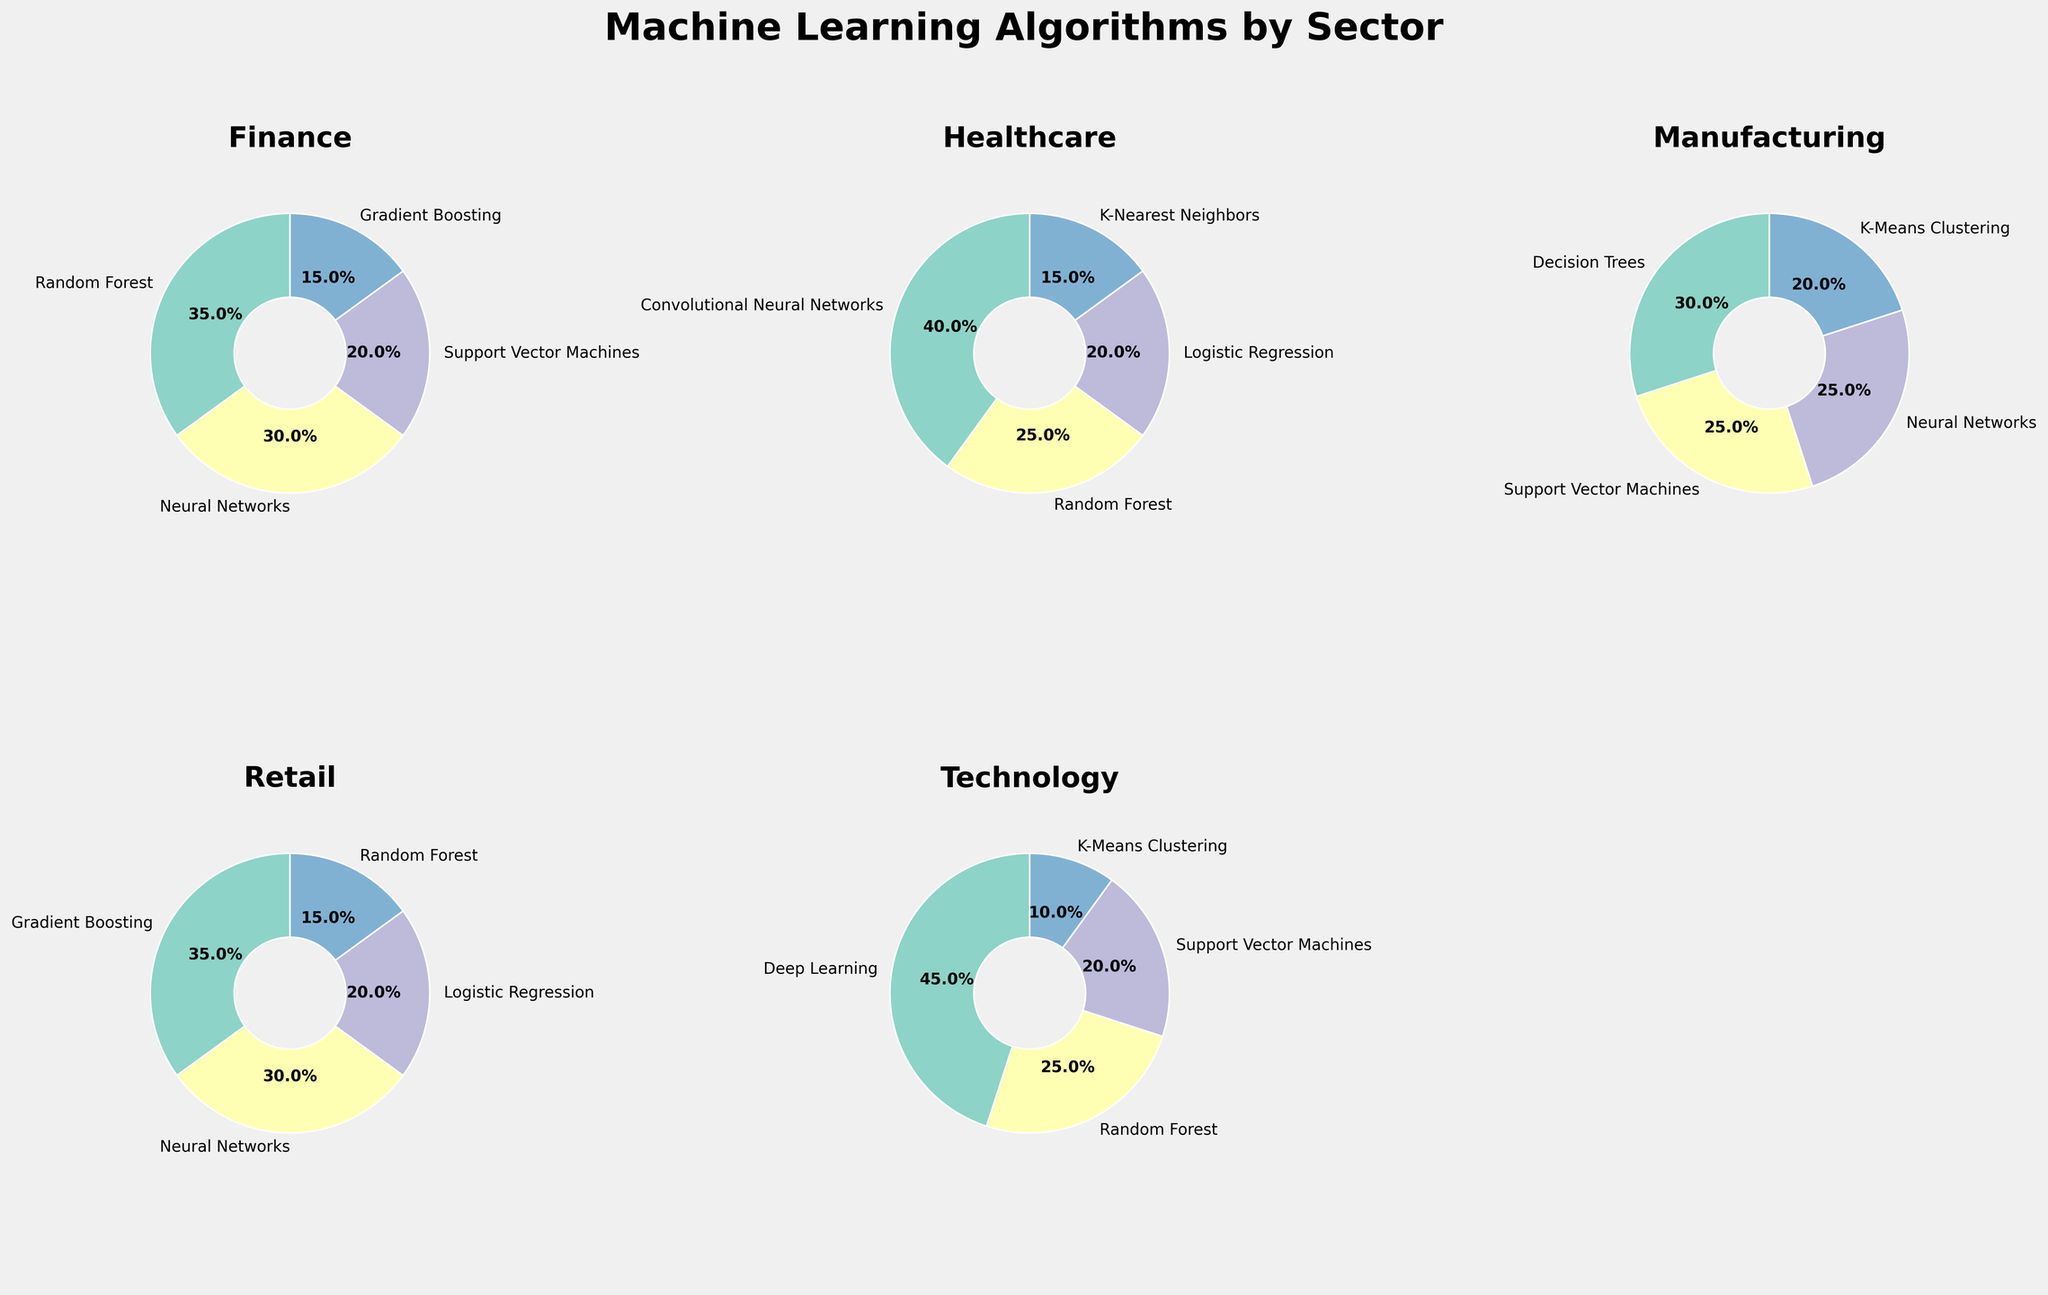Which sector has the highest percentage use of Neural Networks? Look at each pie chart and identify the percentage usage of Neural Networks; The Finance sector uses it at 30%, Healthcare at 0%, Manufacturing at 25%, Retail at 30%, and Technology at 0%.
Answer: Retail and Finance Which algorithm is used the least in the Technology sector? Examine the pie chart for the Technology sector and find the algorithm with the smallest percentage; K-Means Clustering is at 10%.
Answer: K-Means Clustering 